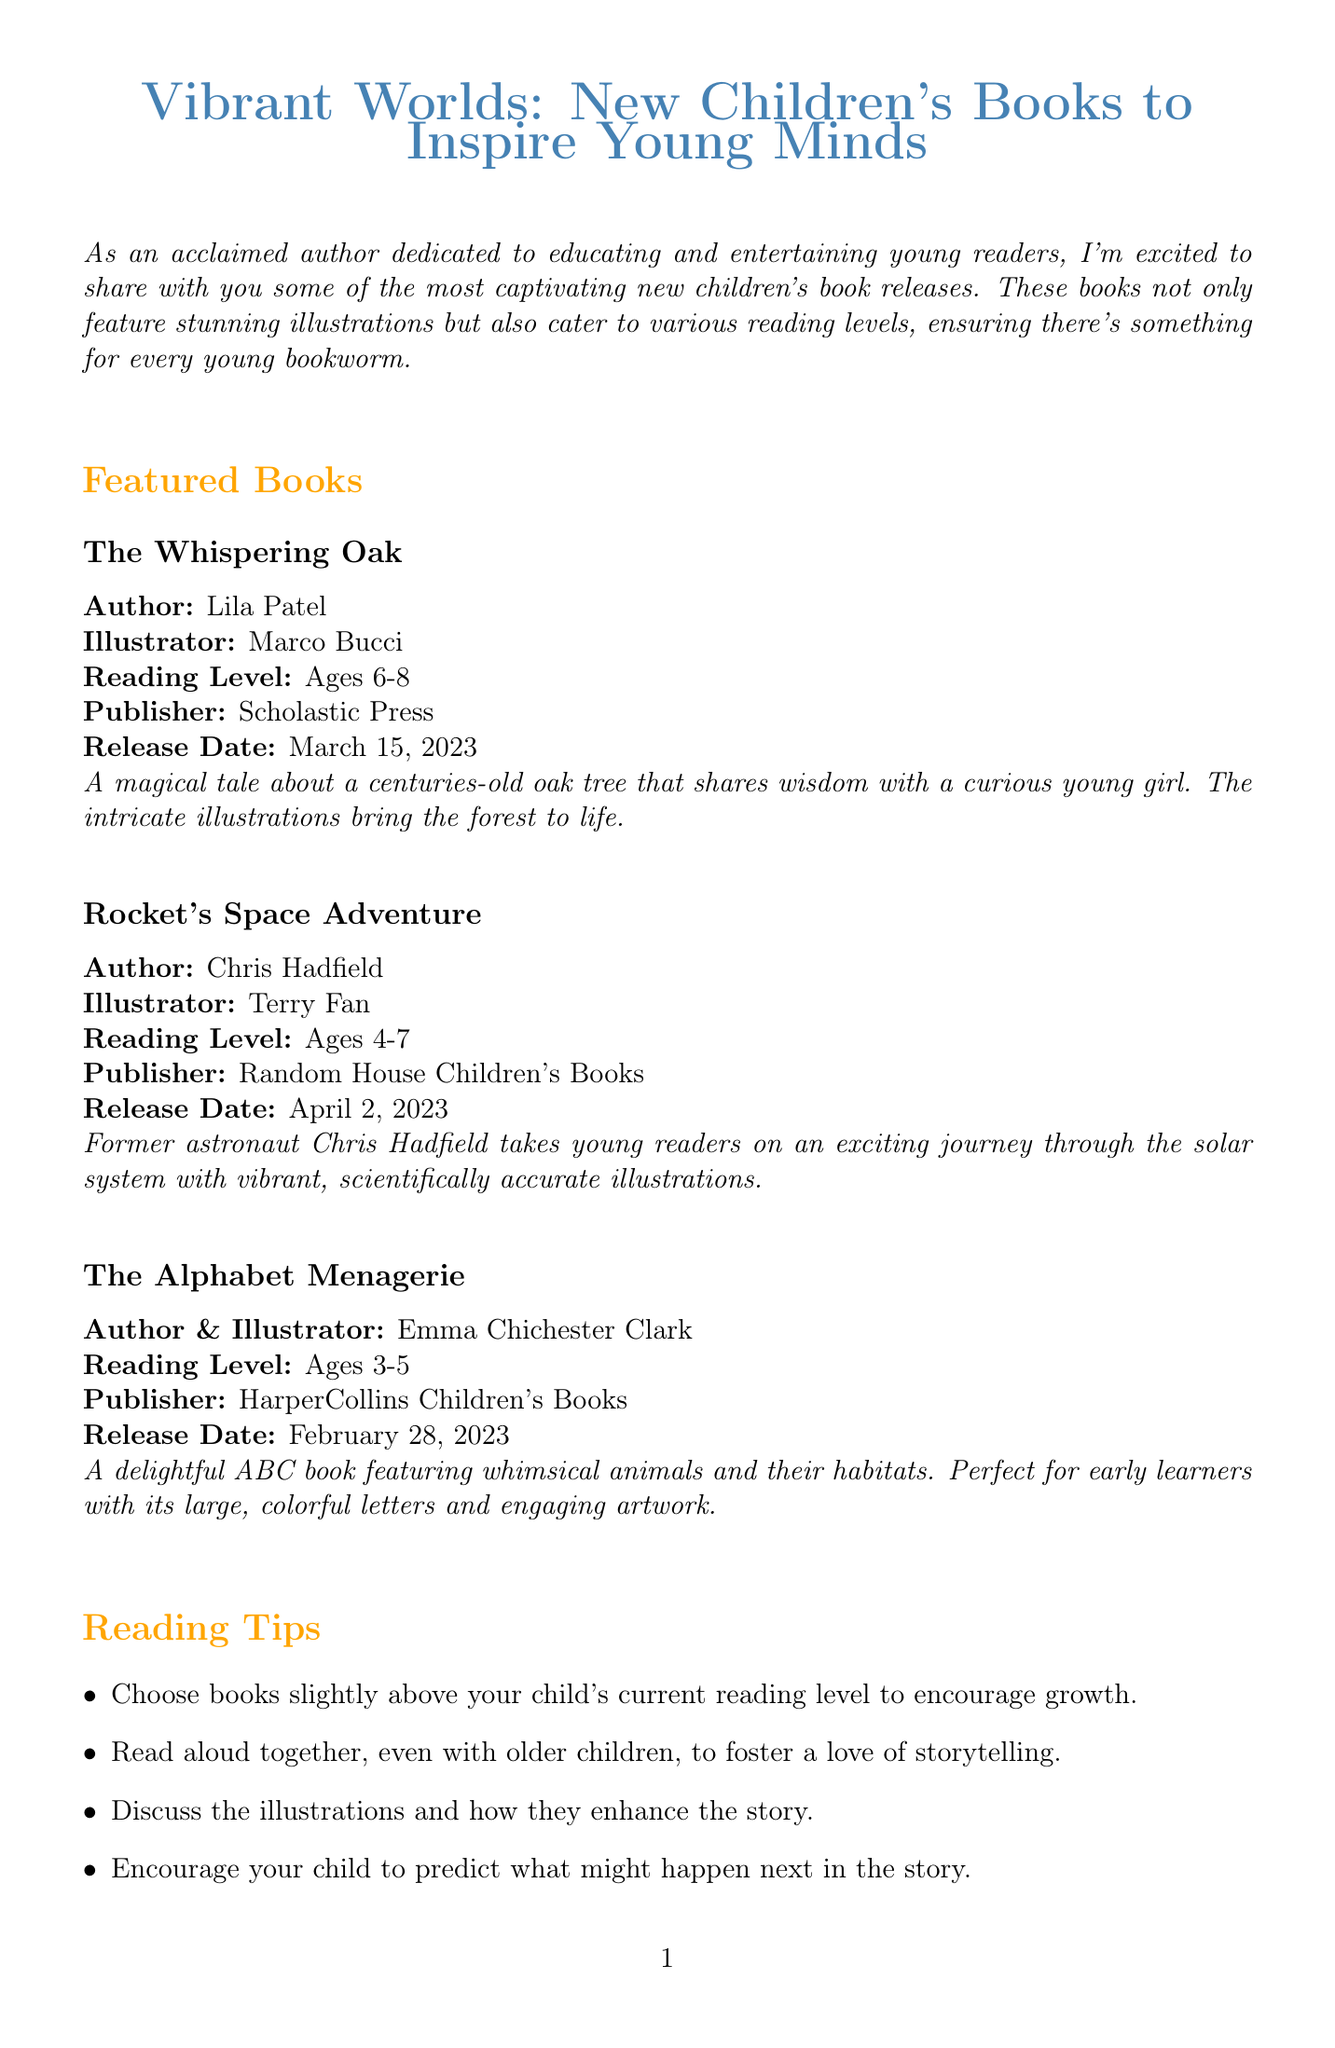What is the title of the newsletter? The title of the newsletter is presented prominently at the beginning of the document.
Answer: Vibrant Worlds: New Children's Books to Inspire Young Minds Who is the author of "The Whispering Oak"? The author of "The Whispering Oak" is listed alongside the book details in the featured books section.
Answer: Lila Patel What age group is "Rocket's Space Adventure" recommended for? The recommended age group is specified directly under the book title in the newsletter.
Answer: Ages 4-7 What is the release date of "The Alphabet Menagerie"? The release date is mentioned in the details for each featured book.
Answer: February 28, 2023 How many reading tips are provided in the newsletter? The number of reading tips can be counted from the list in the reading tips section.
Answer: Four Which event features author readings and workshops? The upcoming events section describes the events and their activities.
Answer: Children's Book Week Celebration Who illustrated "Rocket's Space Adventure"? The illustrator's name is included in the featured book's details.
Answer: Terry Fan What type of content does the introduction highlight? The introduction summarizes the main focus of the newsletter.
Answer: Captivating new children's book releases What is the aim of the suggested reading tips? The reading tips serve a specific purpose outlined within their section.
Answer: To encourage growth in reading skills 